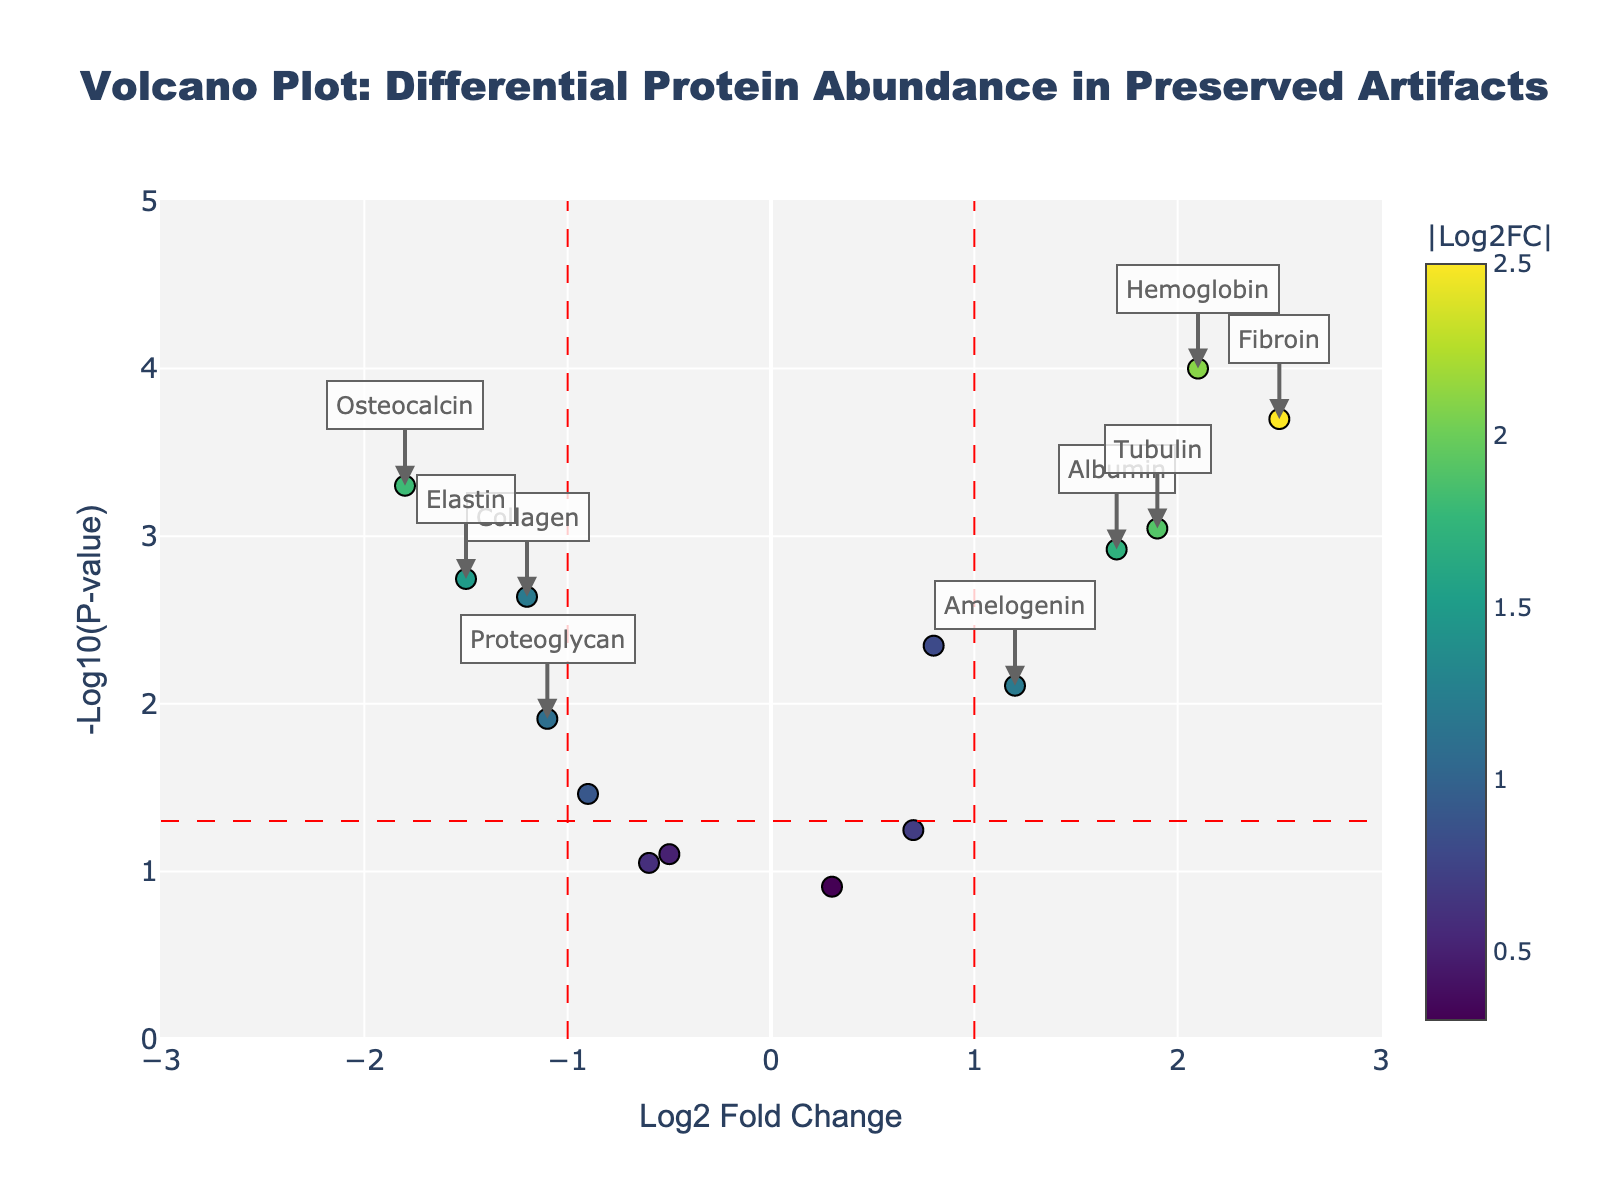What is the title of the figure? The title is typically placed at the top of the figure. Observing the top, we see the title, "Volcano Plot: Differential Protein Abundance in Preserved Artifacts."
Answer: Volcano Plot: Differential Protein Abundance in Preserved Artifacts What does the x-axis represent? The x-axis label is given at the bottom of the figure, where it states "Log2 Fold Change." This indicates it represents the log2-transformed fold change of protein abundance.
Answer: Log2 Fold Change What is the P-value for the protein with the lowest fold change? The protein with the lowest fold change has the most negative Log2FoldChange value, which is Osteocalcin. Its hover text reveals a P-value of 0.0005.
Answer: 0.0005 Which proteins have a negative fold change and are statistically significant? Proteins with a negative fold change have Log2FoldChange < 0, and being statistically significant requires a P-value < 0.05. Checking all such proteins that satisfy these criteria: Collagen (Log2FC = -1.2, P-value = 0.0023), Osteocalcin (Log2FC = -1.8, P-value = 0.0005), Elastin (Log2FC = -1.5, P-value = 0.0018), and Proteoglycan (Log2FC = -1.1, P-value = 0.0123).
Answer: Collagen, Osteocalcin, Elastin, Proteoglycan Among statistically significant proteins, which has the smallest P-value? The smallest P-value reflects the highest -log10(P-value). Examining the significant proteins, Hemoglobin stands out with a P-value of 0.0001.
Answer: Hemoglobin 